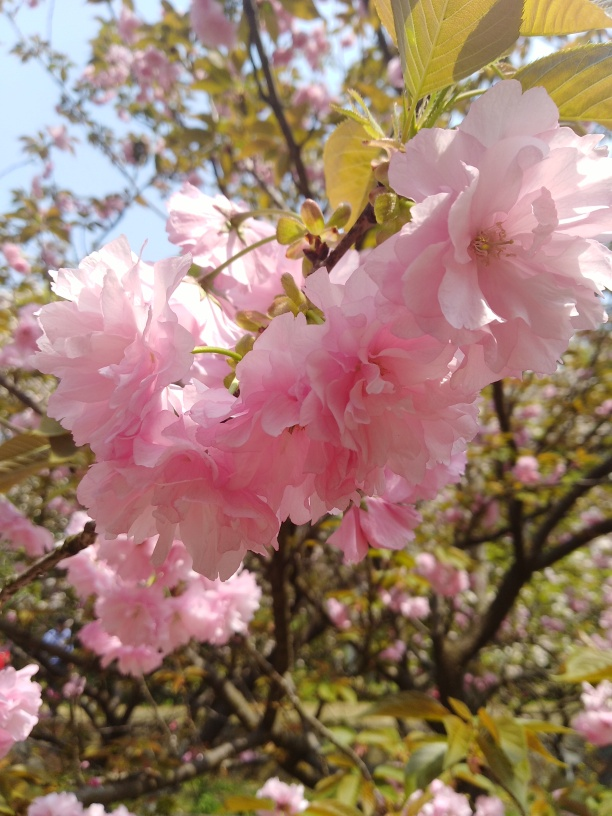What time of year does this tree typically bloom? Cherry blossoms typically bloom during the springtime, with the exact timing dependent on geographical location and annual climate conditions. In Japan, they often bloom around late March to early April, a time celebrated for its natural beauty and the cycle of renewal. 